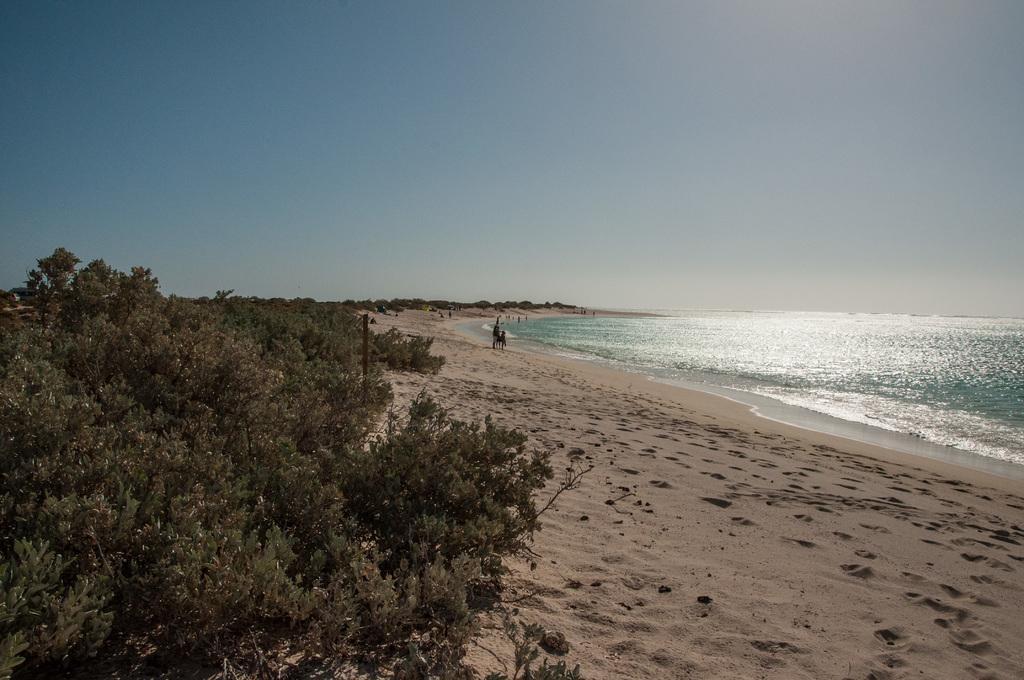Describe this image in one or two sentences. In this picture I can see water and few people on the shore and I can see trees and a blue sky. 